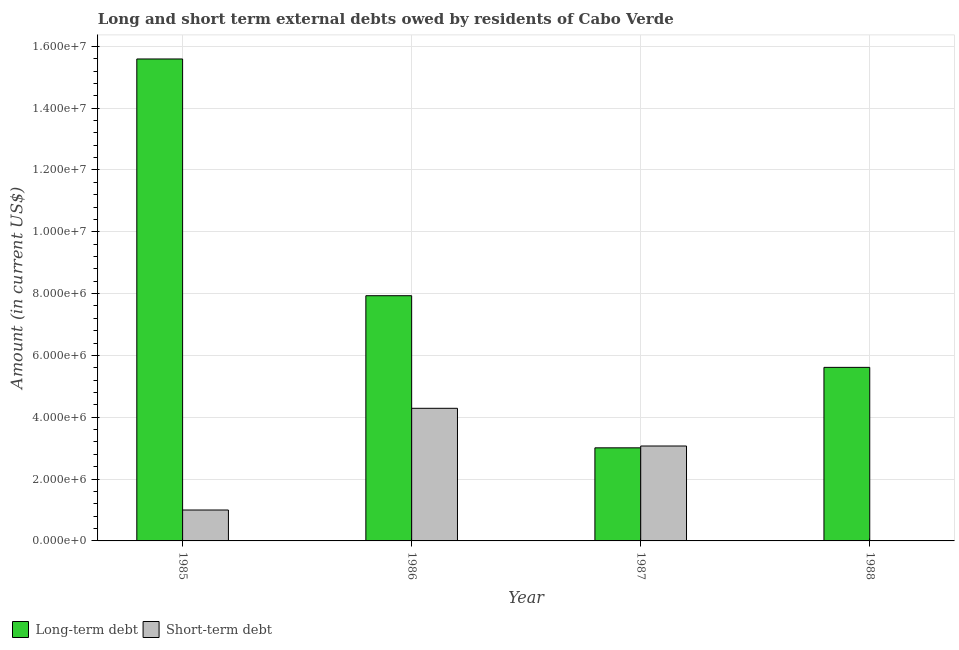How many bars are there on the 2nd tick from the right?
Offer a terse response. 2. What is the label of the 1st group of bars from the left?
Ensure brevity in your answer.  1985. What is the short-term debts owed by residents in 1987?
Your response must be concise. 3.07e+06. Across all years, what is the maximum long-term debts owed by residents?
Offer a very short reply. 1.56e+07. Across all years, what is the minimum short-term debts owed by residents?
Your response must be concise. 0. In which year was the short-term debts owed by residents maximum?
Offer a terse response. 1986. What is the total short-term debts owed by residents in the graph?
Ensure brevity in your answer.  8.36e+06. What is the difference between the long-term debts owed by residents in 1987 and that in 1988?
Offer a terse response. -2.60e+06. What is the difference between the short-term debts owed by residents in 1986 and the long-term debts owed by residents in 1985?
Give a very brief answer. 3.29e+06. What is the average long-term debts owed by residents per year?
Give a very brief answer. 8.04e+06. In how many years, is the short-term debts owed by residents greater than 14800000 US$?
Make the answer very short. 0. What is the ratio of the long-term debts owed by residents in 1987 to that in 1988?
Provide a short and direct response. 0.54. What is the difference between the highest and the second highest short-term debts owed by residents?
Your response must be concise. 1.22e+06. What is the difference between the highest and the lowest short-term debts owed by residents?
Your response must be concise. 4.29e+06. How many bars are there?
Provide a succinct answer. 7. How many years are there in the graph?
Offer a very short reply. 4. Are the values on the major ticks of Y-axis written in scientific E-notation?
Make the answer very short. Yes. Does the graph contain grids?
Your answer should be very brief. Yes. How are the legend labels stacked?
Your answer should be compact. Horizontal. What is the title of the graph?
Provide a succinct answer. Long and short term external debts owed by residents of Cabo Verde. What is the label or title of the X-axis?
Give a very brief answer. Year. What is the label or title of the Y-axis?
Your answer should be compact. Amount (in current US$). What is the Amount (in current US$) in Long-term debt in 1985?
Provide a succinct answer. 1.56e+07. What is the Amount (in current US$) in Short-term debt in 1985?
Your answer should be very brief. 1.00e+06. What is the Amount (in current US$) of Long-term debt in 1986?
Give a very brief answer. 7.93e+06. What is the Amount (in current US$) of Short-term debt in 1986?
Your answer should be compact. 4.29e+06. What is the Amount (in current US$) in Long-term debt in 1987?
Provide a succinct answer. 3.01e+06. What is the Amount (in current US$) in Short-term debt in 1987?
Ensure brevity in your answer.  3.07e+06. What is the Amount (in current US$) of Long-term debt in 1988?
Your answer should be compact. 5.61e+06. What is the Amount (in current US$) of Short-term debt in 1988?
Your answer should be very brief. 0. Across all years, what is the maximum Amount (in current US$) in Long-term debt?
Your answer should be very brief. 1.56e+07. Across all years, what is the maximum Amount (in current US$) in Short-term debt?
Provide a succinct answer. 4.29e+06. Across all years, what is the minimum Amount (in current US$) in Long-term debt?
Ensure brevity in your answer.  3.01e+06. Across all years, what is the minimum Amount (in current US$) in Short-term debt?
Keep it short and to the point. 0. What is the total Amount (in current US$) in Long-term debt in the graph?
Your answer should be very brief. 3.21e+07. What is the total Amount (in current US$) of Short-term debt in the graph?
Your response must be concise. 8.36e+06. What is the difference between the Amount (in current US$) in Long-term debt in 1985 and that in 1986?
Ensure brevity in your answer.  7.66e+06. What is the difference between the Amount (in current US$) of Short-term debt in 1985 and that in 1986?
Provide a succinct answer. -3.29e+06. What is the difference between the Amount (in current US$) in Long-term debt in 1985 and that in 1987?
Give a very brief answer. 1.26e+07. What is the difference between the Amount (in current US$) in Short-term debt in 1985 and that in 1987?
Your answer should be compact. -2.07e+06. What is the difference between the Amount (in current US$) in Long-term debt in 1985 and that in 1988?
Ensure brevity in your answer.  9.98e+06. What is the difference between the Amount (in current US$) in Long-term debt in 1986 and that in 1987?
Offer a terse response. 4.92e+06. What is the difference between the Amount (in current US$) in Short-term debt in 1986 and that in 1987?
Make the answer very short. 1.22e+06. What is the difference between the Amount (in current US$) in Long-term debt in 1986 and that in 1988?
Ensure brevity in your answer.  2.32e+06. What is the difference between the Amount (in current US$) of Long-term debt in 1987 and that in 1988?
Ensure brevity in your answer.  -2.60e+06. What is the difference between the Amount (in current US$) of Long-term debt in 1985 and the Amount (in current US$) of Short-term debt in 1986?
Your response must be concise. 1.13e+07. What is the difference between the Amount (in current US$) of Long-term debt in 1985 and the Amount (in current US$) of Short-term debt in 1987?
Ensure brevity in your answer.  1.25e+07. What is the difference between the Amount (in current US$) of Long-term debt in 1986 and the Amount (in current US$) of Short-term debt in 1987?
Offer a terse response. 4.86e+06. What is the average Amount (in current US$) of Long-term debt per year?
Ensure brevity in your answer.  8.04e+06. What is the average Amount (in current US$) in Short-term debt per year?
Make the answer very short. 2.09e+06. In the year 1985, what is the difference between the Amount (in current US$) in Long-term debt and Amount (in current US$) in Short-term debt?
Your answer should be very brief. 1.46e+07. In the year 1986, what is the difference between the Amount (in current US$) in Long-term debt and Amount (in current US$) in Short-term debt?
Your response must be concise. 3.64e+06. In the year 1987, what is the difference between the Amount (in current US$) of Long-term debt and Amount (in current US$) of Short-term debt?
Offer a terse response. -5.90e+04. What is the ratio of the Amount (in current US$) in Long-term debt in 1985 to that in 1986?
Ensure brevity in your answer.  1.97. What is the ratio of the Amount (in current US$) of Short-term debt in 1985 to that in 1986?
Your answer should be very brief. 0.23. What is the ratio of the Amount (in current US$) in Long-term debt in 1985 to that in 1987?
Keep it short and to the point. 5.18. What is the ratio of the Amount (in current US$) of Short-term debt in 1985 to that in 1987?
Offer a very short reply. 0.33. What is the ratio of the Amount (in current US$) of Long-term debt in 1985 to that in 1988?
Keep it short and to the point. 2.78. What is the ratio of the Amount (in current US$) in Long-term debt in 1986 to that in 1987?
Make the answer very short. 2.63. What is the ratio of the Amount (in current US$) of Short-term debt in 1986 to that in 1987?
Your answer should be very brief. 1.4. What is the ratio of the Amount (in current US$) in Long-term debt in 1986 to that in 1988?
Give a very brief answer. 1.41. What is the ratio of the Amount (in current US$) in Long-term debt in 1987 to that in 1988?
Provide a succinct answer. 0.54. What is the difference between the highest and the second highest Amount (in current US$) of Long-term debt?
Provide a short and direct response. 7.66e+06. What is the difference between the highest and the second highest Amount (in current US$) of Short-term debt?
Your response must be concise. 1.22e+06. What is the difference between the highest and the lowest Amount (in current US$) of Long-term debt?
Your response must be concise. 1.26e+07. What is the difference between the highest and the lowest Amount (in current US$) in Short-term debt?
Your answer should be compact. 4.29e+06. 